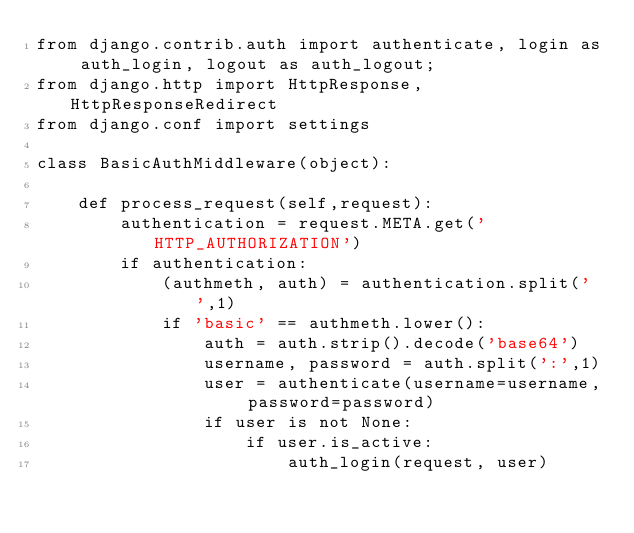<code> <loc_0><loc_0><loc_500><loc_500><_Python_>from django.contrib.auth import authenticate, login as auth_login, logout as auth_logout;
from django.http import HttpResponse, HttpResponseRedirect
from django.conf import settings

class BasicAuthMiddleware(object):

    def process_request(self,request):
        authentication = request.META.get('HTTP_AUTHORIZATION')
        if authentication:
            (authmeth, auth) = authentication.split(' ',1)
            if 'basic' == authmeth.lower():
                auth = auth.strip().decode('base64')
                username, password = auth.split(':',1)
                user = authenticate(username=username, password=password)
                if user is not None:
                    if user.is_active:
                        auth_login(request, user)
</code> 